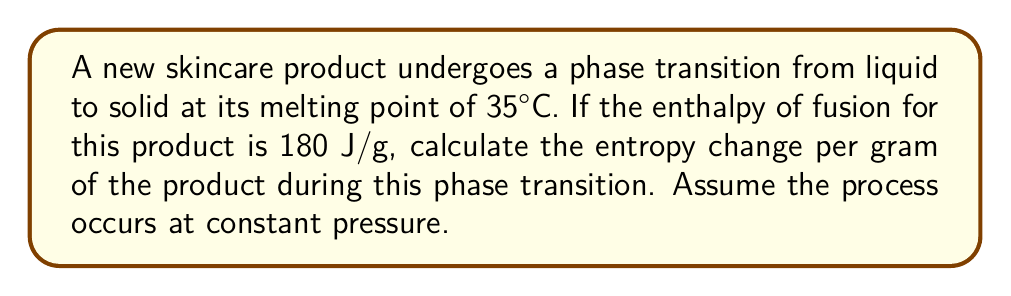Help me with this question. To solve this problem, we'll use the equation for entropy change during a phase transition at constant temperature and pressure:

$$\Delta S = \frac{\Delta H_{fusion}}{T}$$

Where:
$\Delta S$ is the entropy change
$\Delta H_{fusion}$ is the enthalpy of fusion
$T$ is the temperature at which the phase transition occurs

Step 1: Convert the temperature to Kelvin
$$T = 35°C + 273.15 = 308.15 K$$

Step 2: Express the enthalpy of fusion in J/g
$\Delta H_{fusion} = 180 \text{ J/g}$ (already given)

Step 3: Apply the formula
$$\Delta S = \frac{180 \text{ J/g}}{308.15 \text{ K}}$$

Step 4: Calculate the result
$$\Delta S = 0.5842 \text{ J/(g·K)}$$

This positive value indicates an increase in entropy as the product transitions from liquid to solid, which is consistent with the second law of thermodynamics for a spontaneous process.
Answer: 0.5842 J/(g·K) 